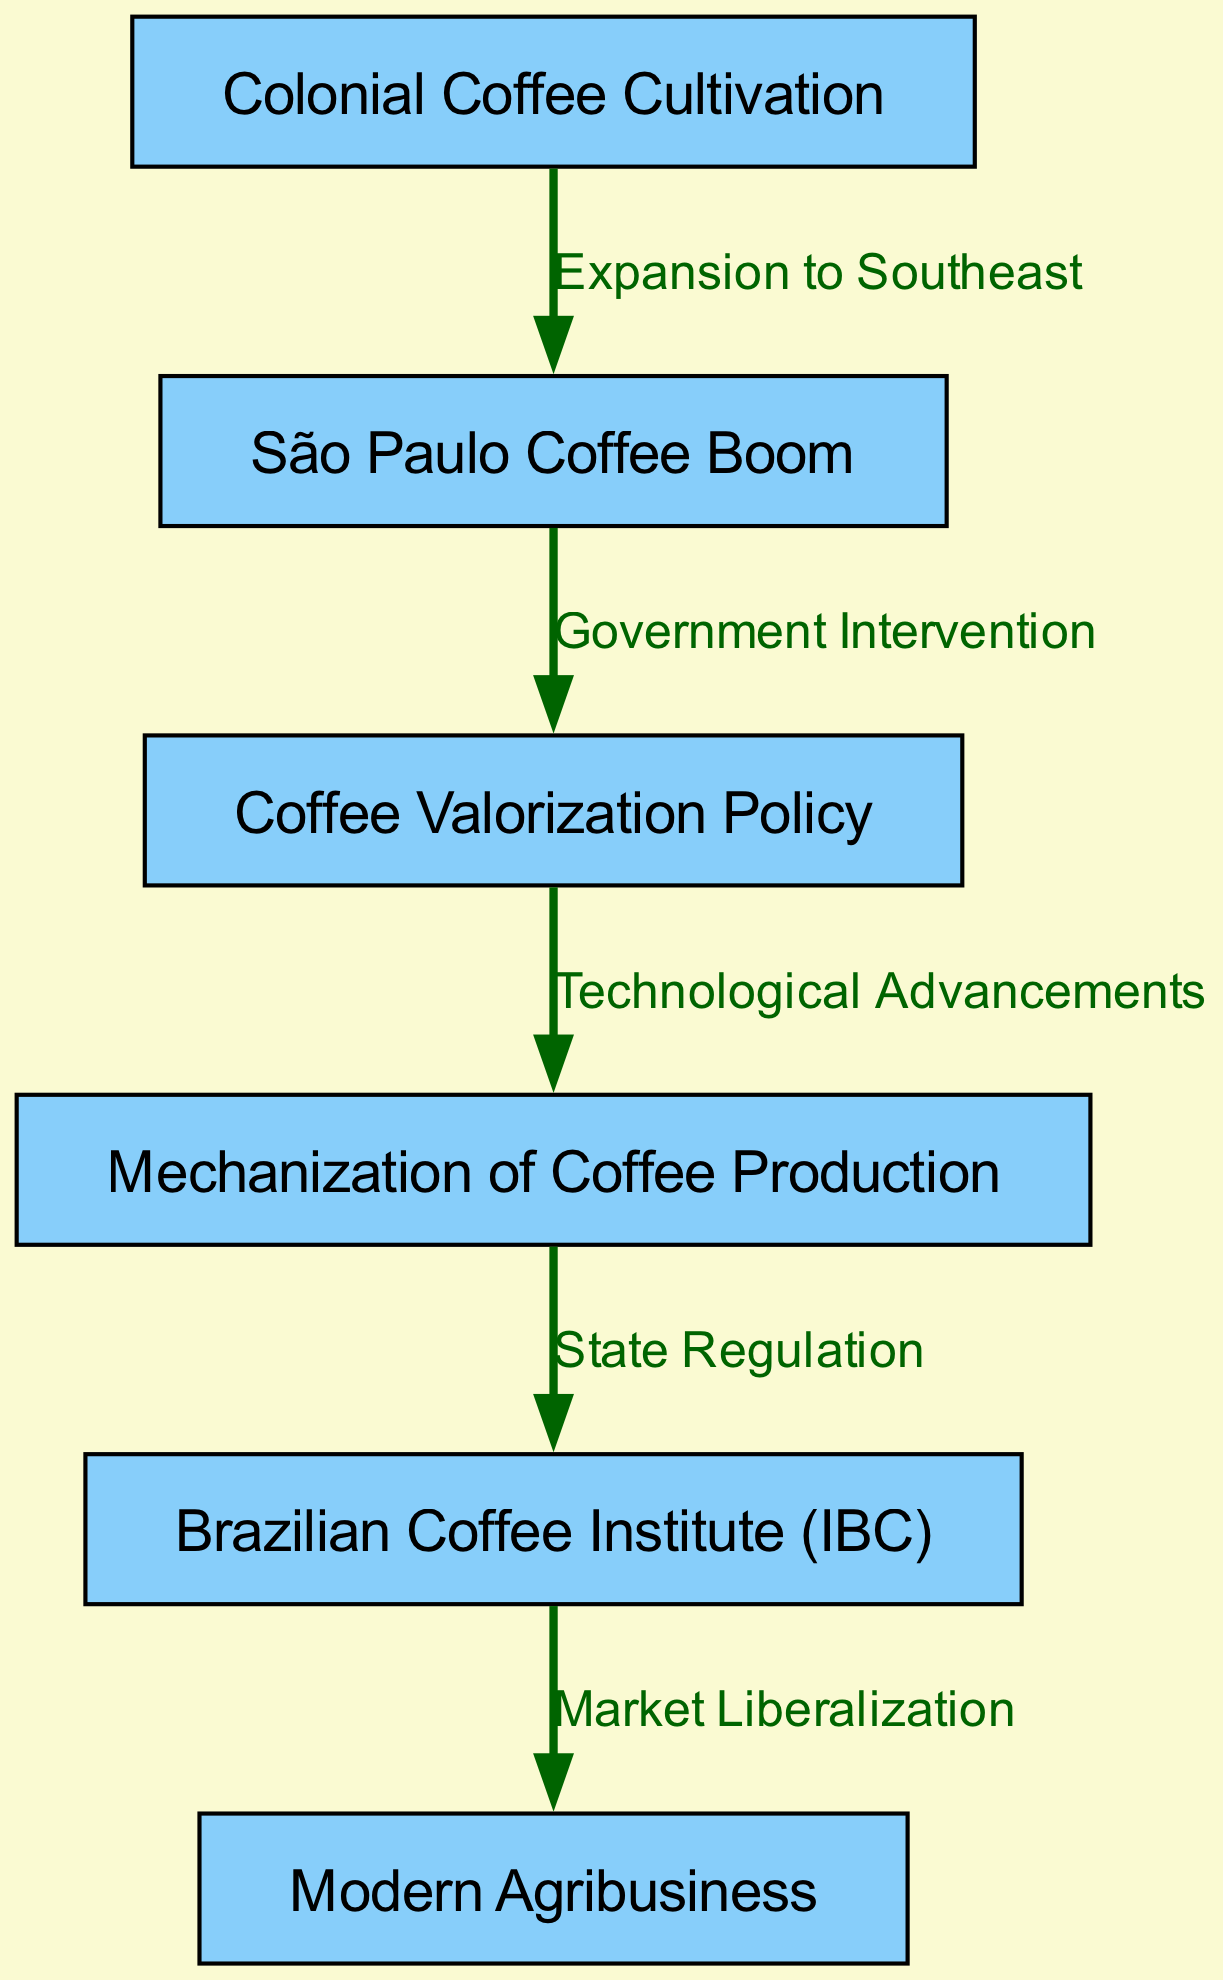What is the first node in the diagram? The first node in the diagram is identified as "Colonial Coffee Cultivation," which is denoted by its specific label.
Answer: Colonial Coffee Cultivation How many nodes are present in the diagram? By counting the list of nodes provided in the diagram, we see there are a total of six distinct nodes representing various stages of the coffee industry evolution.
Answer: 6 What does the edge from "São Paulo Coffee Boom" to "Coffee Valorization Policy" represent? This edge showcases a connection labeled "Government Intervention," indicating that there was governmental action influencing the transition between these two points in the coffee industry's evolution.
Answer: Government Intervention Which node comes after "Mechanization of Coffee Production"? The node that follows "Mechanization of Coffee Production" is labeled "Brazilian Coffee Institute (IBC)," which illustrates the sequence in the evolution of the coffee industry, showing the progression from mechanization to state regulation.
Answer: Brazilian Coffee Institute (IBC) What is the relationship described by the edge from "Brazilian Coffee Institute (IBC)" to "Modern Agribusiness"? The edge indicates "Market Liberalization," which suggests that the establishment of the Brazilian Coffee Institute led to a more open market environment for coffee production, representing a significant development in the industry's evolution.
Answer: Market Liberalization What type of diagram is used to illustrate the flow of the coffee industry evolution? This diagram is a flowchart, designed to depict the progression and relationships among different stages and developments within Brazil's coffee industry over time.
Answer: Flowchart Explain the transition from "Coffee Valorization Policy" to "Mechanization of Coffee Production." What does it indicate? The transition is marked by "Technological Advancements," which indicates that governmental policies aimed at supporting coffee prices possibly led to investments in technology, enhancing coffee production methods and efficiency.
Answer: Technological Advancements 